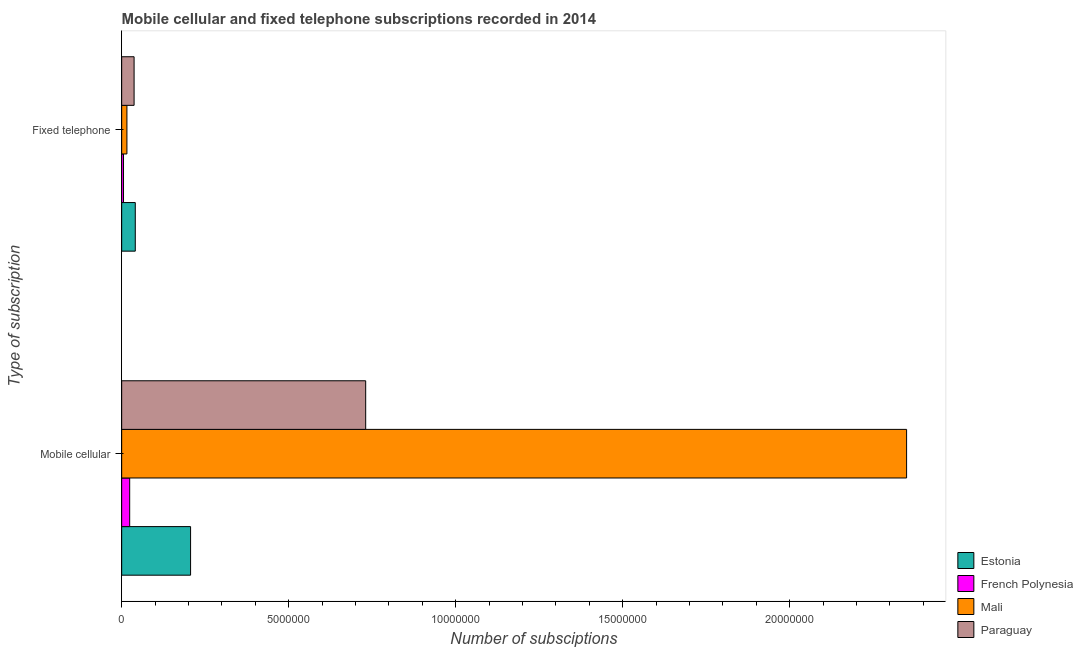What is the label of the 1st group of bars from the top?
Give a very brief answer. Fixed telephone. What is the number of mobile cellular subscriptions in French Polynesia?
Offer a very short reply. 2.40e+05. Across all countries, what is the maximum number of fixed telephone subscriptions?
Ensure brevity in your answer.  4.07e+05. Across all countries, what is the minimum number of fixed telephone subscriptions?
Keep it short and to the point. 5.50e+04. In which country was the number of fixed telephone subscriptions maximum?
Make the answer very short. Estonia. In which country was the number of fixed telephone subscriptions minimum?
Provide a short and direct response. French Polynesia. What is the total number of fixed telephone subscriptions in the graph?
Your answer should be very brief. 9.91e+05. What is the difference between the number of mobile cellular subscriptions in Paraguay and that in Estonia?
Give a very brief answer. 5.24e+06. What is the difference between the number of fixed telephone subscriptions in Mali and the number of mobile cellular subscriptions in Paraguay?
Make the answer very short. -7.15e+06. What is the average number of fixed telephone subscriptions per country?
Your answer should be compact. 2.48e+05. What is the difference between the number of fixed telephone subscriptions and number of mobile cellular subscriptions in French Polynesia?
Provide a succinct answer. -1.85e+05. What is the ratio of the number of mobile cellular subscriptions in Paraguay to that in Estonia?
Offer a terse response. 3.54. In how many countries, is the number of fixed telephone subscriptions greater than the average number of fixed telephone subscriptions taken over all countries?
Keep it short and to the point. 2. What does the 4th bar from the top in Mobile cellular represents?
Offer a terse response. Estonia. What does the 1st bar from the bottom in Fixed telephone represents?
Ensure brevity in your answer.  Estonia. How many bars are there?
Your response must be concise. 8. Are all the bars in the graph horizontal?
Give a very brief answer. Yes. What is the difference between two consecutive major ticks on the X-axis?
Offer a very short reply. 5.00e+06. Are the values on the major ticks of X-axis written in scientific E-notation?
Your answer should be compact. No. How are the legend labels stacked?
Provide a succinct answer. Vertical. What is the title of the graph?
Your answer should be very brief. Mobile cellular and fixed telephone subscriptions recorded in 2014. Does "Sweden" appear as one of the legend labels in the graph?
Ensure brevity in your answer.  No. What is the label or title of the X-axis?
Your answer should be very brief. Number of subsciptions. What is the label or title of the Y-axis?
Ensure brevity in your answer.  Type of subscription. What is the Number of subsciptions of Estonia in Mobile cellular?
Provide a short and direct response. 2.06e+06. What is the Number of subsciptions in French Polynesia in Mobile cellular?
Ensure brevity in your answer.  2.40e+05. What is the Number of subsciptions of Mali in Mobile cellular?
Offer a terse response. 2.35e+07. What is the Number of subsciptions of Paraguay in Mobile cellular?
Provide a short and direct response. 7.31e+06. What is the Number of subsciptions of Estonia in Fixed telephone?
Provide a succinct answer. 4.07e+05. What is the Number of subsciptions of French Polynesia in Fixed telephone?
Your response must be concise. 5.50e+04. What is the Number of subsciptions of Mali in Fixed telephone?
Make the answer very short. 1.57e+05. What is the Number of subsciptions in Paraguay in Fixed telephone?
Keep it short and to the point. 3.72e+05. Across all Type of subscription, what is the maximum Number of subsciptions in Estonia?
Your response must be concise. 2.06e+06. Across all Type of subscription, what is the maximum Number of subsciptions in French Polynesia?
Your answer should be very brief. 2.40e+05. Across all Type of subscription, what is the maximum Number of subsciptions in Mali?
Your answer should be compact. 2.35e+07. Across all Type of subscription, what is the maximum Number of subsciptions in Paraguay?
Your response must be concise. 7.31e+06. Across all Type of subscription, what is the minimum Number of subsciptions of Estonia?
Keep it short and to the point. 4.07e+05. Across all Type of subscription, what is the minimum Number of subsciptions in French Polynesia?
Keep it short and to the point. 5.50e+04. Across all Type of subscription, what is the minimum Number of subsciptions of Mali?
Make the answer very short. 1.57e+05. Across all Type of subscription, what is the minimum Number of subsciptions of Paraguay?
Offer a very short reply. 3.72e+05. What is the total Number of subsciptions in Estonia in the graph?
Offer a very short reply. 2.47e+06. What is the total Number of subsciptions in French Polynesia in the graph?
Your answer should be compact. 2.95e+05. What is the total Number of subsciptions in Mali in the graph?
Your answer should be compact. 2.37e+07. What is the total Number of subsciptions of Paraguay in the graph?
Provide a succinct answer. 7.68e+06. What is the difference between the Number of subsciptions of Estonia in Mobile cellular and that in Fixed telephone?
Your answer should be compact. 1.66e+06. What is the difference between the Number of subsciptions in French Polynesia in Mobile cellular and that in Fixed telephone?
Give a very brief answer. 1.85e+05. What is the difference between the Number of subsciptions in Mali in Mobile cellular and that in Fixed telephone?
Your answer should be compact. 2.33e+07. What is the difference between the Number of subsciptions of Paraguay in Mobile cellular and that in Fixed telephone?
Your response must be concise. 6.93e+06. What is the difference between the Number of subsciptions of Estonia in Mobile cellular and the Number of subsciptions of French Polynesia in Fixed telephone?
Your answer should be very brief. 2.01e+06. What is the difference between the Number of subsciptions of Estonia in Mobile cellular and the Number of subsciptions of Mali in Fixed telephone?
Give a very brief answer. 1.91e+06. What is the difference between the Number of subsciptions in Estonia in Mobile cellular and the Number of subsciptions in Paraguay in Fixed telephone?
Provide a succinct answer. 1.69e+06. What is the difference between the Number of subsciptions in French Polynesia in Mobile cellular and the Number of subsciptions in Mali in Fixed telephone?
Keep it short and to the point. 8.26e+04. What is the difference between the Number of subsciptions of French Polynesia in Mobile cellular and the Number of subsciptions of Paraguay in Fixed telephone?
Offer a very short reply. -1.32e+05. What is the difference between the Number of subsciptions in Mali in Mobile cellular and the Number of subsciptions in Paraguay in Fixed telephone?
Offer a terse response. 2.31e+07. What is the average Number of subsciptions in Estonia per Type of subscription?
Keep it short and to the point. 1.24e+06. What is the average Number of subsciptions of French Polynesia per Type of subscription?
Offer a very short reply. 1.47e+05. What is the average Number of subsciptions in Mali per Type of subscription?
Give a very brief answer. 1.18e+07. What is the average Number of subsciptions of Paraguay per Type of subscription?
Provide a succinct answer. 3.84e+06. What is the difference between the Number of subsciptions in Estonia and Number of subsciptions in French Polynesia in Mobile cellular?
Offer a terse response. 1.82e+06. What is the difference between the Number of subsciptions in Estonia and Number of subsciptions in Mali in Mobile cellular?
Your answer should be very brief. -2.14e+07. What is the difference between the Number of subsciptions in Estonia and Number of subsciptions in Paraguay in Mobile cellular?
Provide a short and direct response. -5.24e+06. What is the difference between the Number of subsciptions of French Polynesia and Number of subsciptions of Mali in Mobile cellular?
Offer a terse response. -2.33e+07. What is the difference between the Number of subsciptions of French Polynesia and Number of subsciptions of Paraguay in Mobile cellular?
Your answer should be very brief. -7.07e+06. What is the difference between the Number of subsciptions of Mali and Number of subsciptions of Paraguay in Mobile cellular?
Ensure brevity in your answer.  1.62e+07. What is the difference between the Number of subsciptions of Estonia and Number of subsciptions of French Polynesia in Fixed telephone?
Offer a terse response. 3.52e+05. What is the difference between the Number of subsciptions in Estonia and Number of subsciptions in Mali in Fixed telephone?
Make the answer very short. 2.50e+05. What is the difference between the Number of subsciptions of Estonia and Number of subsciptions of Paraguay in Fixed telephone?
Give a very brief answer. 3.54e+04. What is the difference between the Number of subsciptions in French Polynesia and Number of subsciptions in Mali in Fixed telephone?
Your response must be concise. -1.02e+05. What is the difference between the Number of subsciptions in French Polynesia and Number of subsciptions in Paraguay in Fixed telephone?
Your answer should be very brief. -3.17e+05. What is the difference between the Number of subsciptions in Mali and Number of subsciptions in Paraguay in Fixed telephone?
Offer a terse response. -2.15e+05. What is the ratio of the Number of subsciptions of Estonia in Mobile cellular to that in Fixed telephone?
Give a very brief answer. 5.06. What is the ratio of the Number of subsciptions of French Polynesia in Mobile cellular to that in Fixed telephone?
Your answer should be compact. 4.36. What is the ratio of the Number of subsciptions of Mali in Mobile cellular to that in Fixed telephone?
Offer a very short reply. 149.54. What is the ratio of the Number of subsciptions in Paraguay in Mobile cellular to that in Fixed telephone?
Provide a succinct answer. 19.64. What is the difference between the highest and the second highest Number of subsciptions of Estonia?
Your response must be concise. 1.66e+06. What is the difference between the highest and the second highest Number of subsciptions in French Polynesia?
Provide a succinct answer. 1.85e+05. What is the difference between the highest and the second highest Number of subsciptions in Mali?
Provide a succinct answer. 2.33e+07. What is the difference between the highest and the second highest Number of subsciptions in Paraguay?
Provide a short and direct response. 6.93e+06. What is the difference between the highest and the lowest Number of subsciptions in Estonia?
Offer a very short reply. 1.66e+06. What is the difference between the highest and the lowest Number of subsciptions in French Polynesia?
Give a very brief answer. 1.85e+05. What is the difference between the highest and the lowest Number of subsciptions of Mali?
Your response must be concise. 2.33e+07. What is the difference between the highest and the lowest Number of subsciptions of Paraguay?
Make the answer very short. 6.93e+06. 